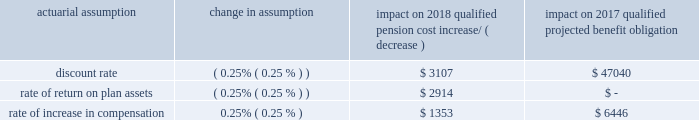Nuclear decommissioning costs see 201cnuclear decommissioning costs 201d in the 201ccritical accounting estimates 201d section of entergy corporation and subsidiaries management 2019s financial discussion and analysis for discussion of the estimates inherent in accounting for nuclear decommissioning costs .
Utility regulatory accounting see 201cutility regulatory accounting 201d in the 201ccritical accounting estimates 201d section of entergy corporation and subsidiaries management 2019s financial discussion and analysis for discussion of accounting for the effects of rate regulation .
Unbilled revenue see 201cunbilled revenue 201d in the 201ccritical accounting estimates 201d section of entergy corporation and subsidiaries management 2019s financial discussion and analysis for discussion of the estimates associated with the unbilled revenue amounts .
Impairment of long-lived assets and trust fund investments see 201cimpairment of long-lived assets and trust fund investments 201d in the 201ccritical accounting estimates 201d section of entergy corporation and subsidiaries management 2019s financial discussion and analysis for discussion of the estimates associated with the impairment of long-lived assets and trust fund investments .
Taxation and uncertain tax positions see 201ctaxation and uncertain tax positions 201d in the 201ccritical accounting estimates 201d section of entergy corporation and subsidiaries management 2019s financial discussion and analysis for further discussion .
Qualified pension and other postretirement benefits entergy arkansas 2019s qualified pension and other postretirement reported costs , as described in note 11 to the financial statements , are impacted by numerous factors including the provisions of the plans , changing employee demographics , and various actuarial calculations , assumptions , and accounting mechanisms . a0 a0 a0see the 201cqualified pension and other postretirement benefits 201d in the 201ccritical accounting estimates 201d section of entergy corporation and subsidiaries management 2019s financial discussion and analysis for further discussion . a0 a0because of the complexity of these calculations , the long-term nature of these obligations , and the importance of the assumptions utilized , entergy 2019s estimate of these costs is a critical accounting estimate .
Costs and sensitivities the following chart reflects the sensitivity of qualified pension cost and qualified projected benefit obligation to changes in certain actuarial assumptions ( dollars in thousands ) .
Actuarial assumption change in assumption impact on 2018 qualified pension cost impact on 2017 qualified projected benefit obligation increase/ ( decrease ) .
Entergy arkansas , inc .
And subsidiaries management 2019s financial discussion and analysis .
What was the ratio of the discount rate on the impact on 2017 qualified projected benefit obligation to the impact on 2018 qualified pension cost increase? 
Computations: (47040 / 3107)
Answer: 15.14001. 